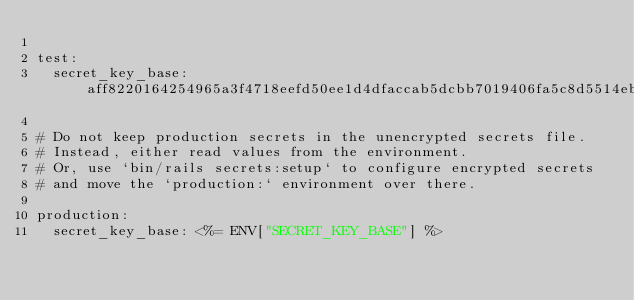<code> <loc_0><loc_0><loc_500><loc_500><_YAML_>
test:
  secret_key_base: aff8220164254965a3f4718eefd50ee1d4dfaccab5dcbb7019406fa5c8d5514eb385db806295f2c938e087fe9cf13bda8d939fad863fe01fe848b931cf53575b

# Do not keep production secrets in the unencrypted secrets file.
# Instead, either read values from the environment.
# Or, use `bin/rails secrets:setup` to configure encrypted secrets
# and move the `production:` environment over there.

production:
  secret_key_base: <%= ENV["SECRET_KEY_BASE"] %>
</code> 